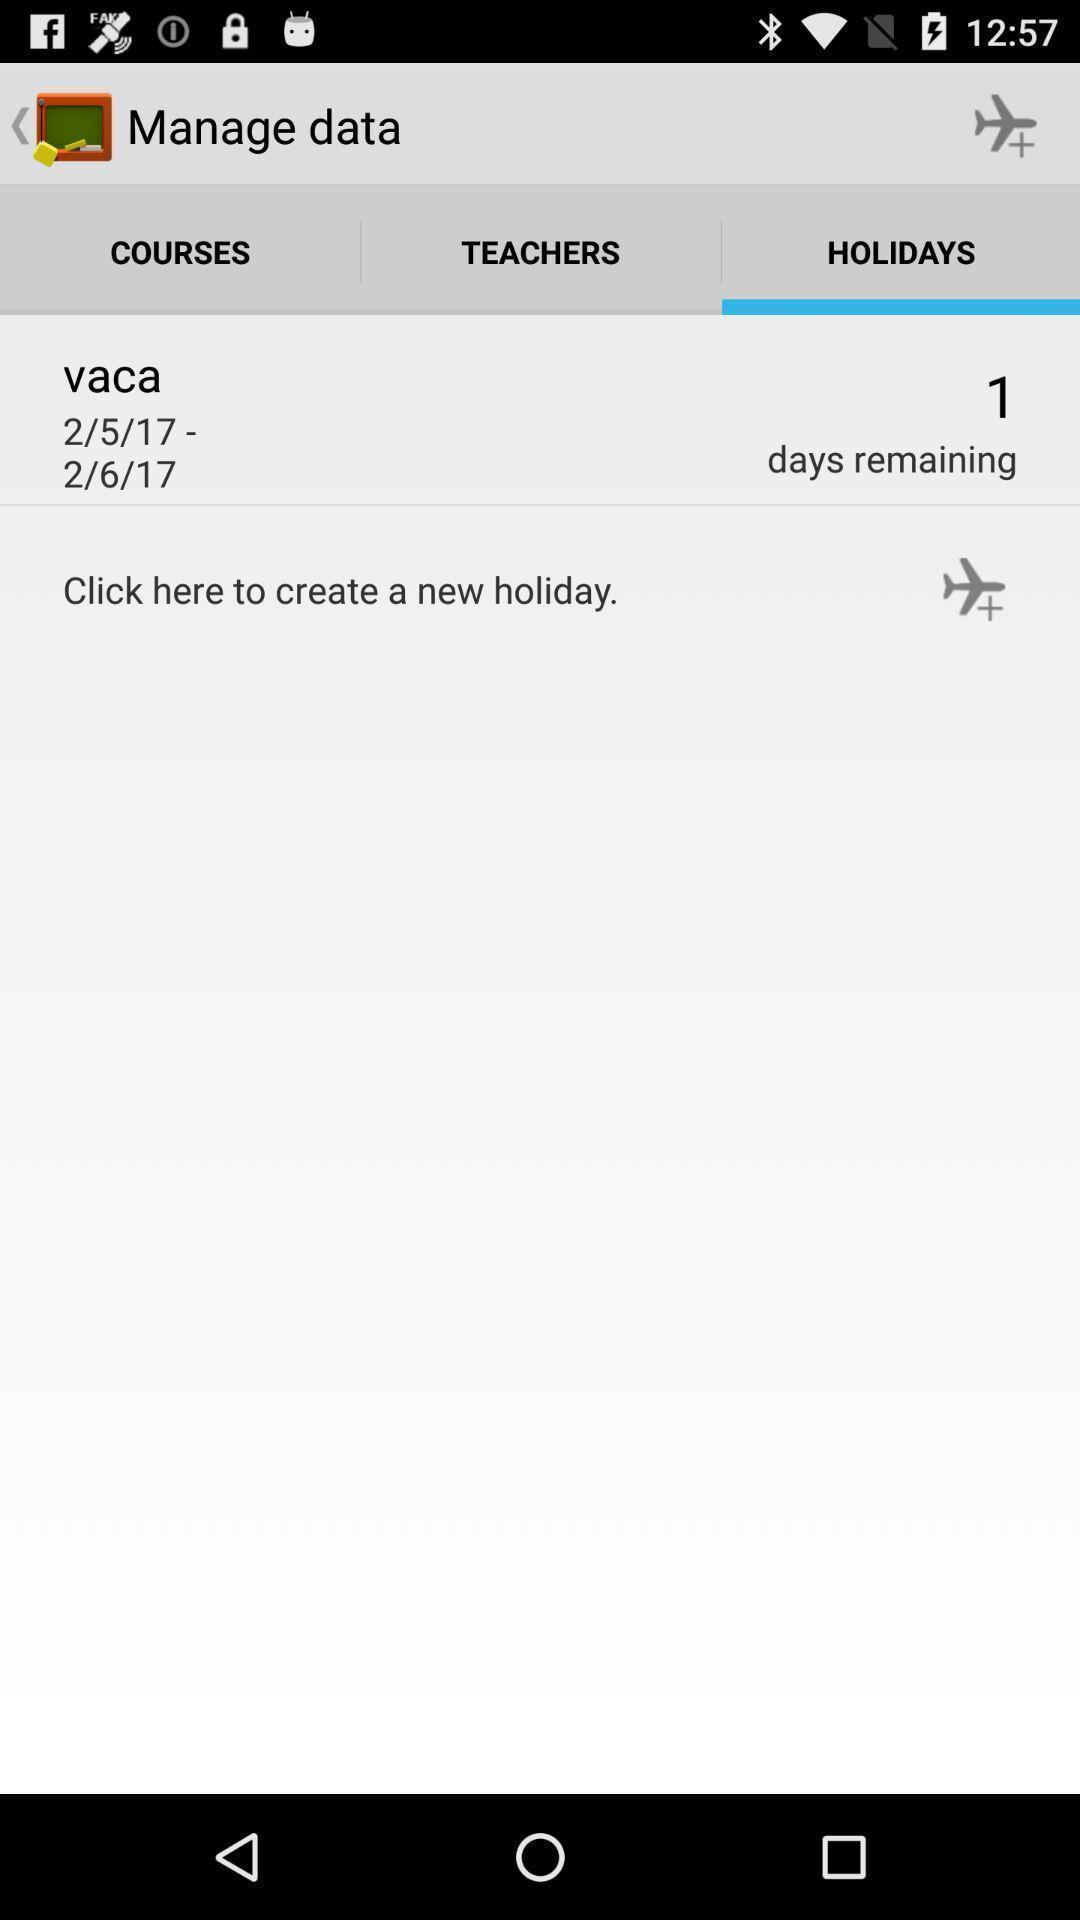Describe the key features of this screenshot. Screen displaying holidays page. 